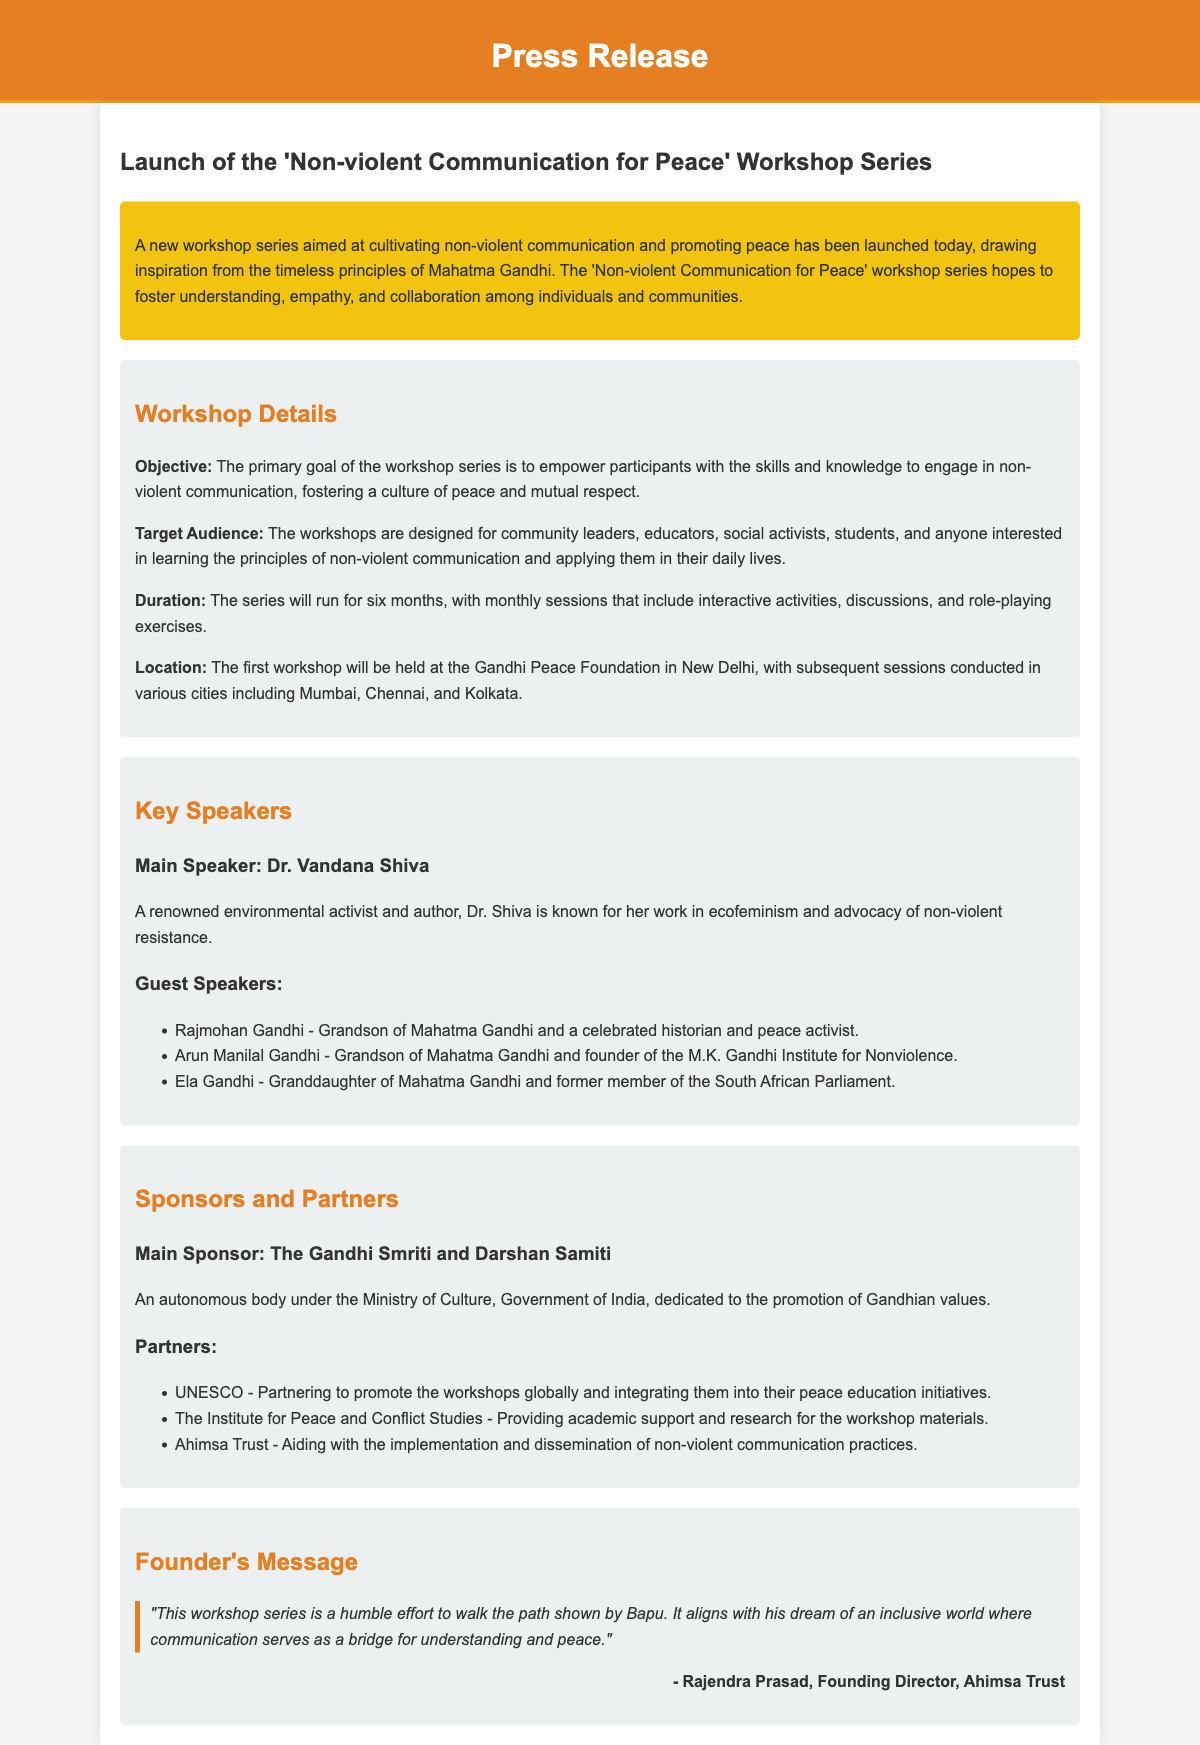What is the title of the workshop series? The title of the workshop series is mentioned in the header of the document.
Answer: Non-violent Communication for Peace What is the primary goal of the workshop series? The primary goal is detailed in the workshop details section.
Answer: Empower participants with the skills and knowledge to engage in non-violent communication Who is the main speaker at the workshops? The main speaker's name is highlighted within the key speakers section.
Answer: Dr. Vandana Shiva How long will the workshop series run? The duration of the series is specified in the details section of the document.
Answer: Six months Where will the first workshop be held? The location of the first workshop is mentioned in the details section.
Answer: Gandhi Peace Foundation, New Delhi Who are the guest speakers listed? The guest speakers are listed below the main speaker in the key speakers section.
Answer: Rajmohan Gandhi, Arun Manilal Gandhi, Ela Gandhi What is the main sponsor of the workshop series? The main sponsor's name is provided in the sponsors section.
Answer: The Gandhi Smriti and Darshan Samiti What does the founder's message emphasize? The founder's message can be inferred from the quote in the message section.
Answer: An inclusive world where communication serves as a bridge for understanding and peace Which organization is partnering to promote the workshops globally? The partner organization is indicated in the sponsors section.
Answer: UNESCO 